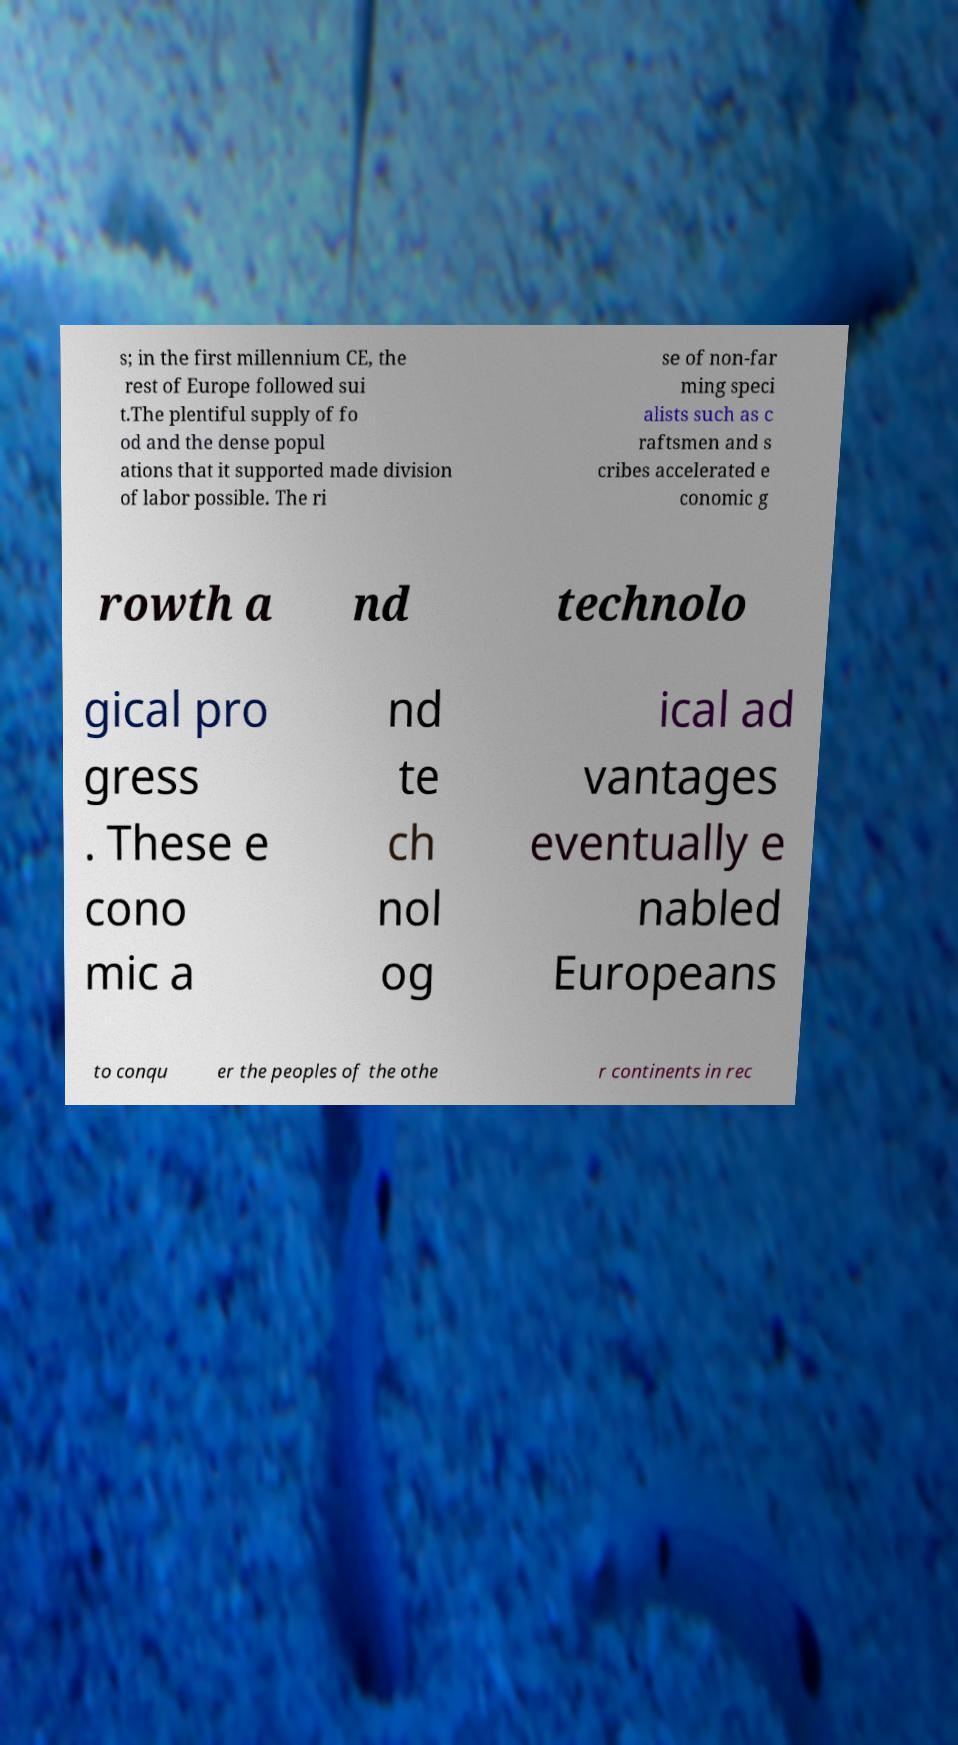For documentation purposes, I need the text within this image transcribed. Could you provide that? s; in the first millennium CE, the rest of Europe followed sui t.The plentiful supply of fo od and the dense popul ations that it supported made division of labor possible. The ri se of non-far ming speci alists such as c raftsmen and s cribes accelerated e conomic g rowth a nd technolo gical pro gress . These e cono mic a nd te ch nol og ical ad vantages eventually e nabled Europeans to conqu er the peoples of the othe r continents in rec 